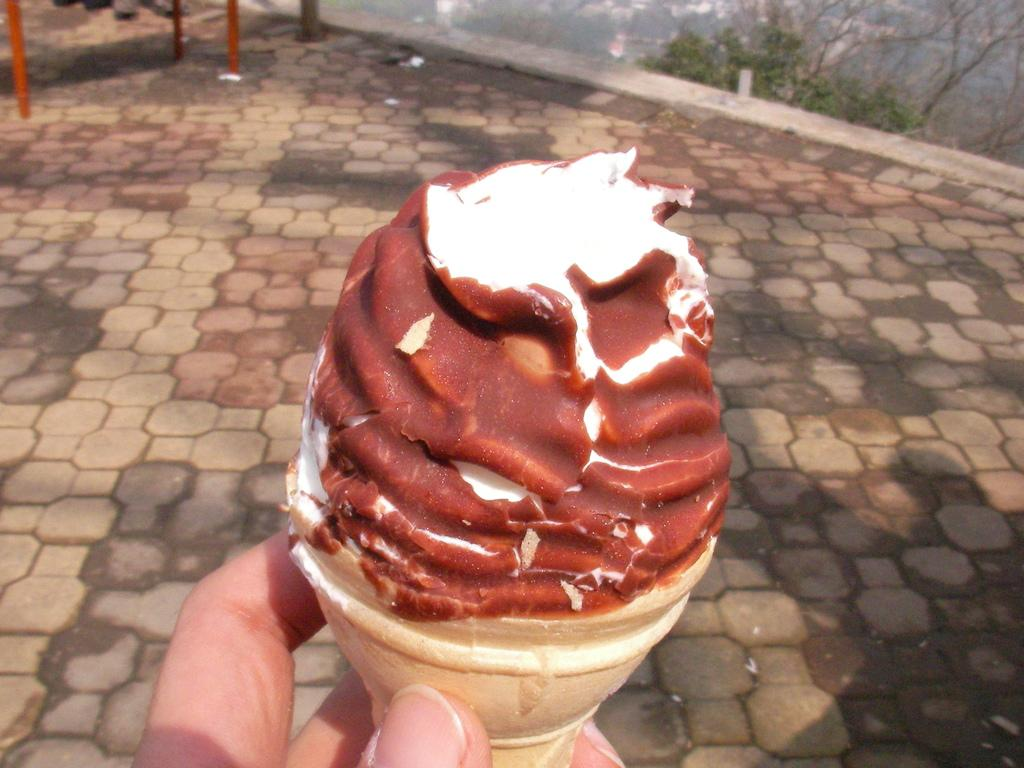What is being held by the fingers in the image? The fingers are holding a cone ice cream. What can be seen in the background of the image? There is a floor visible in the background of the image. What is present at the top of the image? There are rods and trees visible at the top of the image. How many goldfish are swimming in the image? There are no goldfish present in the image. What things are being thought about by the person in the image? The image does not show a person, so it is impossible to determine what they might be thinking about. 